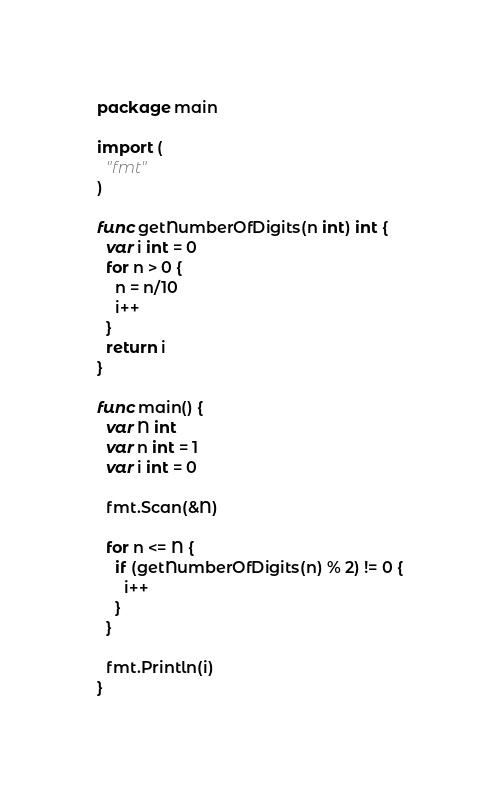Convert code to text. <code><loc_0><loc_0><loc_500><loc_500><_Go_>package main

import (
  "fmt"
)

func getNumberOfDigits(n int) int {
  var i int = 0
  for n > 0 {
    n = n/10
    i++
  }
  return i
}

func main() {
  var N int 
  var n int = 1
  var i int = 0
  
  fmt.Scan(&N)

  for n <= N {
    if (getNumberOfDigits(n) % 2) != 0 {
      i++
    }
  }
  
  fmt.Println(i)
}</code> 